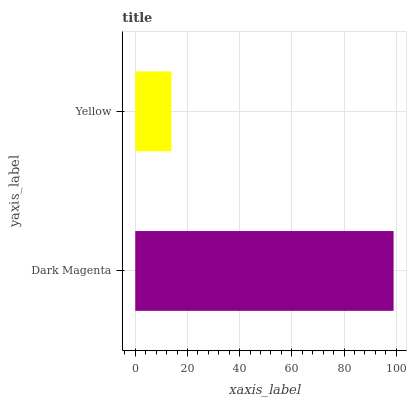Is Yellow the minimum?
Answer yes or no. Yes. Is Dark Magenta the maximum?
Answer yes or no. Yes. Is Yellow the maximum?
Answer yes or no. No. Is Dark Magenta greater than Yellow?
Answer yes or no. Yes. Is Yellow less than Dark Magenta?
Answer yes or no. Yes. Is Yellow greater than Dark Magenta?
Answer yes or no. No. Is Dark Magenta less than Yellow?
Answer yes or no. No. Is Dark Magenta the high median?
Answer yes or no. Yes. Is Yellow the low median?
Answer yes or no. Yes. Is Yellow the high median?
Answer yes or no. No. Is Dark Magenta the low median?
Answer yes or no. No. 